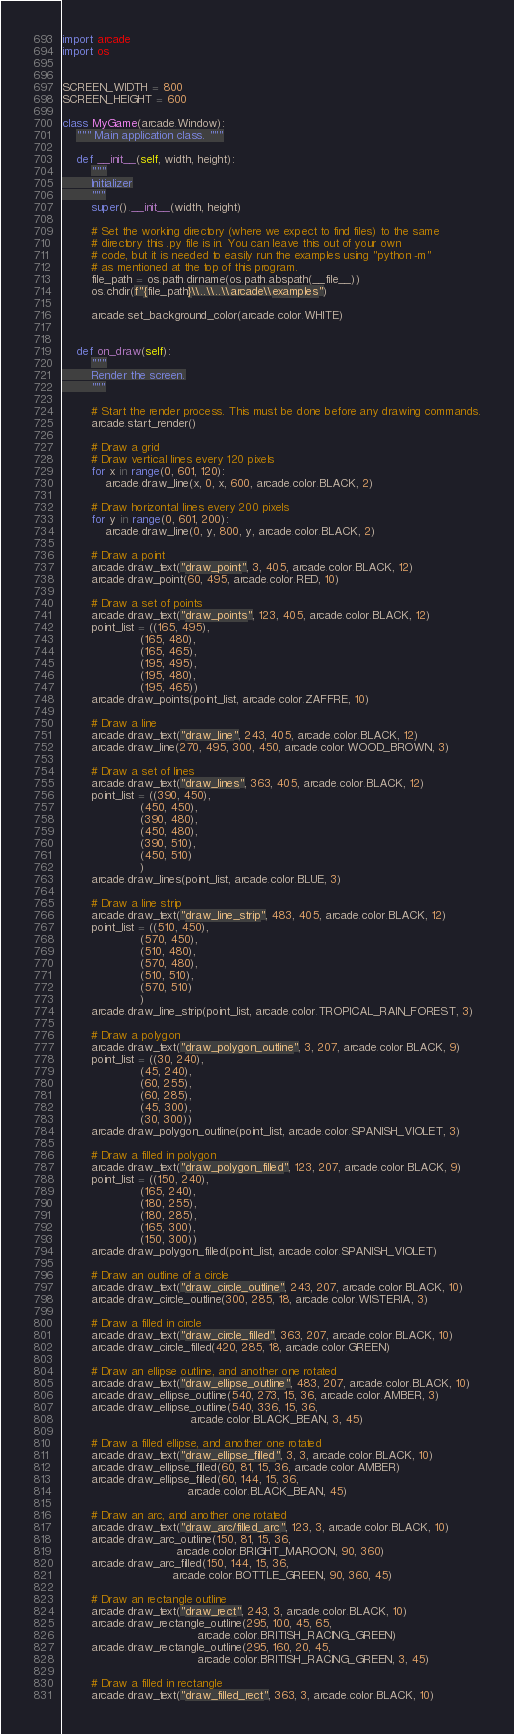<code> <loc_0><loc_0><loc_500><loc_500><_Python_>import arcade
import os


SCREEN_WIDTH = 800
SCREEN_HEIGHT = 600

class MyGame(arcade.Window):
    """ Main application class. """

    def __init__(self, width, height):
        """
        Initializer
        """
        super().__init__(width, height)

        # Set the working directory (where we expect to find files) to the same
        # directory this .py file is in. You can leave this out of your own
        # code, but it is needed to easily run the examples using "python -m"
        # as mentioned at the top of this program.
        file_path = os.path.dirname(os.path.abspath(__file__))
        os.chdir(f"{file_path}\\..\\..\\arcade\\examples")

        arcade.set_background_color(arcade.color.WHITE)


    def on_draw(self):
        """
        Render the screen.
        """

        # Start the render process. This must be done before any drawing commands.
        arcade.start_render()

        # Draw a grid
        # Draw vertical lines every 120 pixels
        for x in range(0, 601, 120):
            arcade.draw_line(x, 0, x, 600, arcade.color.BLACK, 2)

        # Draw horizontal lines every 200 pixels
        for y in range(0, 601, 200):
            arcade.draw_line(0, y, 800, y, arcade.color.BLACK, 2)

        # Draw a point
        arcade.draw_text("draw_point", 3, 405, arcade.color.BLACK, 12)
        arcade.draw_point(60, 495, arcade.color.RED, 10)

        # Draw a set of points
        arcade.draw_text("draw_points", 123, 405, arcade.color.BLACK, 12)
        point_list = ((165, 495),
                      (165, 480),
                      (165, 465),
                      (195, 495),
                      (195, 480),
                      (195, 465))
        arcade.draw_points(point_list, arcade.color.ZAFFRE, 10)

        # Draw a line
        arcade.draw_text("draw_line", 243, 405, arcade.color.BLACK, 12)
        arcade.draw_line(270, 495, 300, 450, arcade.color.WOOD_BROWN, 3)

        # Draw a set of lines
        arcade.draw_text("draw_lines", 363, 405, arcade.color.BLACK, 12)
        point_list = ((390, 450),
                      (450, 450),
                      (390, 480),
                      (450, 480),
                      (390, 510),
                      (450, 510)
                      )
        arcade.draw_lines(point_list, arcade.color.BLUE, 3)

        # Draw a line strip
        arcade.draw_text("draw_line_strip", 483, 405, arcade.color.BLACK, 12)
        point_list = ((510, 450),
                      (570, 450),
                      (510, 480),
                      (570, 480),
                      (510, 510),
                      (570, 510)
                      )
        arcade.draw_line_strip(point_list, arcade.color.TROPICAL_RAIN_FOREST, 3)

        # Draw a polygon
        arcade.draw_text("draw_polygon_outline", 3, 207, arcade.color.BLACK, 9)
        point_list = ((30, 240),
                      (45, 240),
                      (60, 255),
                      (60, 285),
                      (45, 300),
                      (30, 300))
        arcade.draw_polygon_outline(point_list, arcade.color.SPANISH_VIOLET, 3)

        # Draw a filled in polygon
        arcade.draw_text("draw_polygon_filled", 123, 207, arcade.color.BLACK, 9)
        point_list = ((150, 240),
                      (165, 240),
                      (180, 255),
                      (180, 285),
                      (165, 300),
                      (150, 300))
        arcade.draw_polygon_filled(point_list, arcade.color.SPANISH_VIOLET)

        # Draw an outline of a circle
        arcade.draw_text("draw_circle_outline", 243, 207, arcade.color.BLACK, 10)
        arcade.draw_circle_outline(300, 285, 18, arcade.color.WISTERIA, 3)

        # Draw a filled in circle
        arcade.draw_text("draw_circle_filled", 363, 207, arcade.color.BLACK, 10)
        arcade.draw_circle_filled(420, 285, 18, arcade.color.GREEN)

        # Draw an ellipse outline, and another one rotated
        arcade.draw_text("draw_ellipse_outline", 483, 207, arcade.color.BLACK, 10)
        arcade.draw_ellipse_outline(540, 273, 15, 36, arcade.color.AMBER, 3)
        arcade.draw_ellipse_outline(540, 336, 15, 36,
                                    arcade.color.BLACK_BEAN, 3, 45)

        # Draw a filled ellipse, and another one rotated
        arcade.draw_text("draw_ellipse_filled", 3, 3, arcade.color.BLACK, 10)
        arcade.draw_ellipse_filled(60, 81, 15, 36, arcade.color.AMBER)
        arcade.draw_ellipse_filled(60, 144, 15, 36,
                                   arcade.color.BLACK_BEAN, 45)

        # Draw an arc, and another one rotated
        arcade.draw_text("draw_arc/filled_arc", 123, 3, arcade.color.BLACK, 10)
        arcade.draw_arc_outline(150, 81, 15, 36,
                                arcade.color.BRIGHT_MAROON, 90, 360)
        arcade.draw_arc_filled(150, 144, 15, 36,
                               arcade.color.BOTTLE_GREEN, 90, 360, 45)

        # Draw an rectangle outline
        arcade.draw_text("draw_rect", 243, 3, arcade.color.BLACK, 10)
        arcade.draw_rectangle_outline(295, 100, 45, 65,
                                      arcade.color.BRITISH_RACING_GREEN)
        arcade.draw_rectangle_outline(295, 160, 20, 45,
                                      arcade.color.BRITISH_RACING_GREEN, 3, 45)

        # Draw a filled in rectangle
        arcade.draw_text("draw_filled_rect", 363, 3, arcade.color.BLACK, 10)</code> 